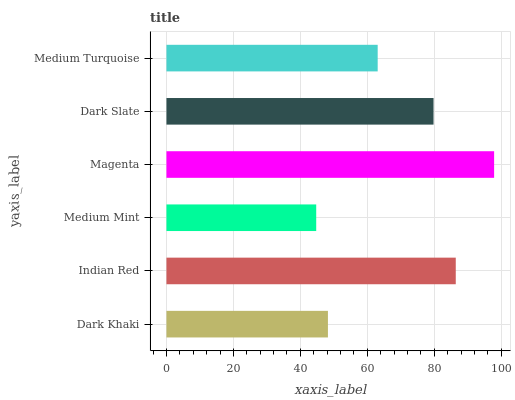Is Medium Mint the minimum?
Answer yes or no. Yes. Is Magenta the maximum?
Answer yes or no. Yes. Is Indian Red the minimum?
Answer yes or no. No. Is Indian Red the maximum?
Answer yes or no. No. Is Indian Red greater than Dark Khaki?
Answer yes or no. Yes. Is Dark Khaki less than Indian Red?
Answer yes or no. Yes. Is Dark Khaki greater than Indian Red?
Answer yes or no. No. Is Indian Red less than Dark Khaki?
Answer yes or no. No. Is Dark Slate the high median?
Answer yes or no. Yes. Is Medium Turquoise the low median?
Answer yes or no. Yes. Is Indian Red the high median?
Answer yes or no. No. Is Magenta the low median?
Answer yes or no. No. 